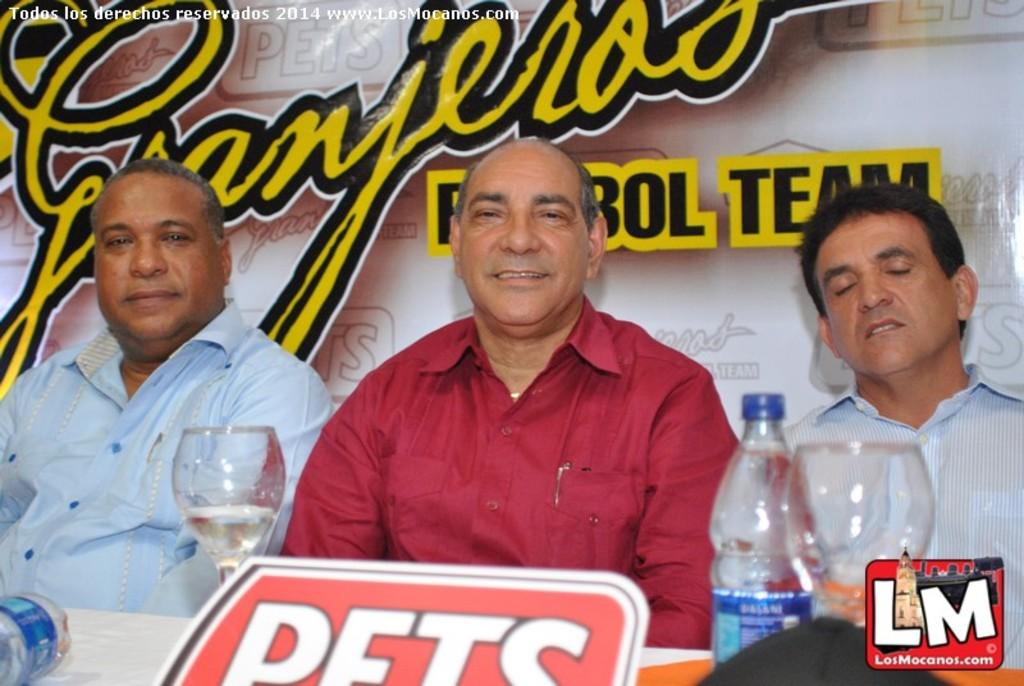<image>
Give a short and clear explanation of the subsequent image. Three men posing for a photo with the sign PETS in front. 